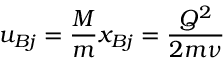Convert formula to latex. <formula><loc_0><loc_0><loc_500><loc_500>u _ { B j } = \frac { M } { m } x _ { B j } = \frac { Q ^ { 2 } } { 2 m \nu }</formula> 